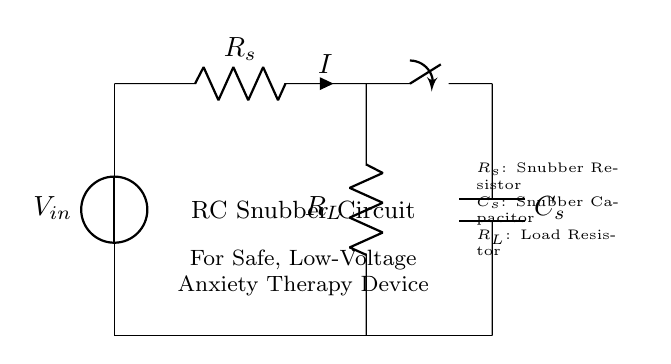What is the input voltage for this circuit? The input voltage is labeled as V_input in the circuit diagram, which represents the voltage source connected to the circuit.
Answer: V_input What are the components used in the RC snubber circuit? The main components in the RC snubber circuit are the resistor labeled R_s, the capacitor labeled C_s, and the load resistor labeled R_L.
Answer: R_s, C_s, R_L What is the purpose of the snubber resistor? The snubber resistor, R_s, is used to dissipate energy and reduce voltage spikes in the circuit, which is particularly important for protecting sensitive components in low-voltage devices.
Answer: Reduce voltage spikes What is the role of the capacitor in the circuit? The capacitor, C_s, in the snubber circuit absorbs and smoothens the voltage fluctuations, providing stability to the circuit during operation.
Answer: Absorb voltage fluctuations How many resistors are present in the circuit? There are two resistors present in the circuit: the snubber resistor R_s and the load resistor R_L, which serve different functions in the circuit.
Answer: Two resistors What happens to the current when the switch is opened? When the switch is opened, the current I will stop flowing through the circuit since the circuit is incomplete, leading to no current flow.
Answer: No current flow What type of circuit is depicted here? The circuit depicted is an RC snubber circuit specifically designed for low-voltage applications, which helps manage transient voltages and reduce anxiety effectively.
Answer: RC snubber circuit 